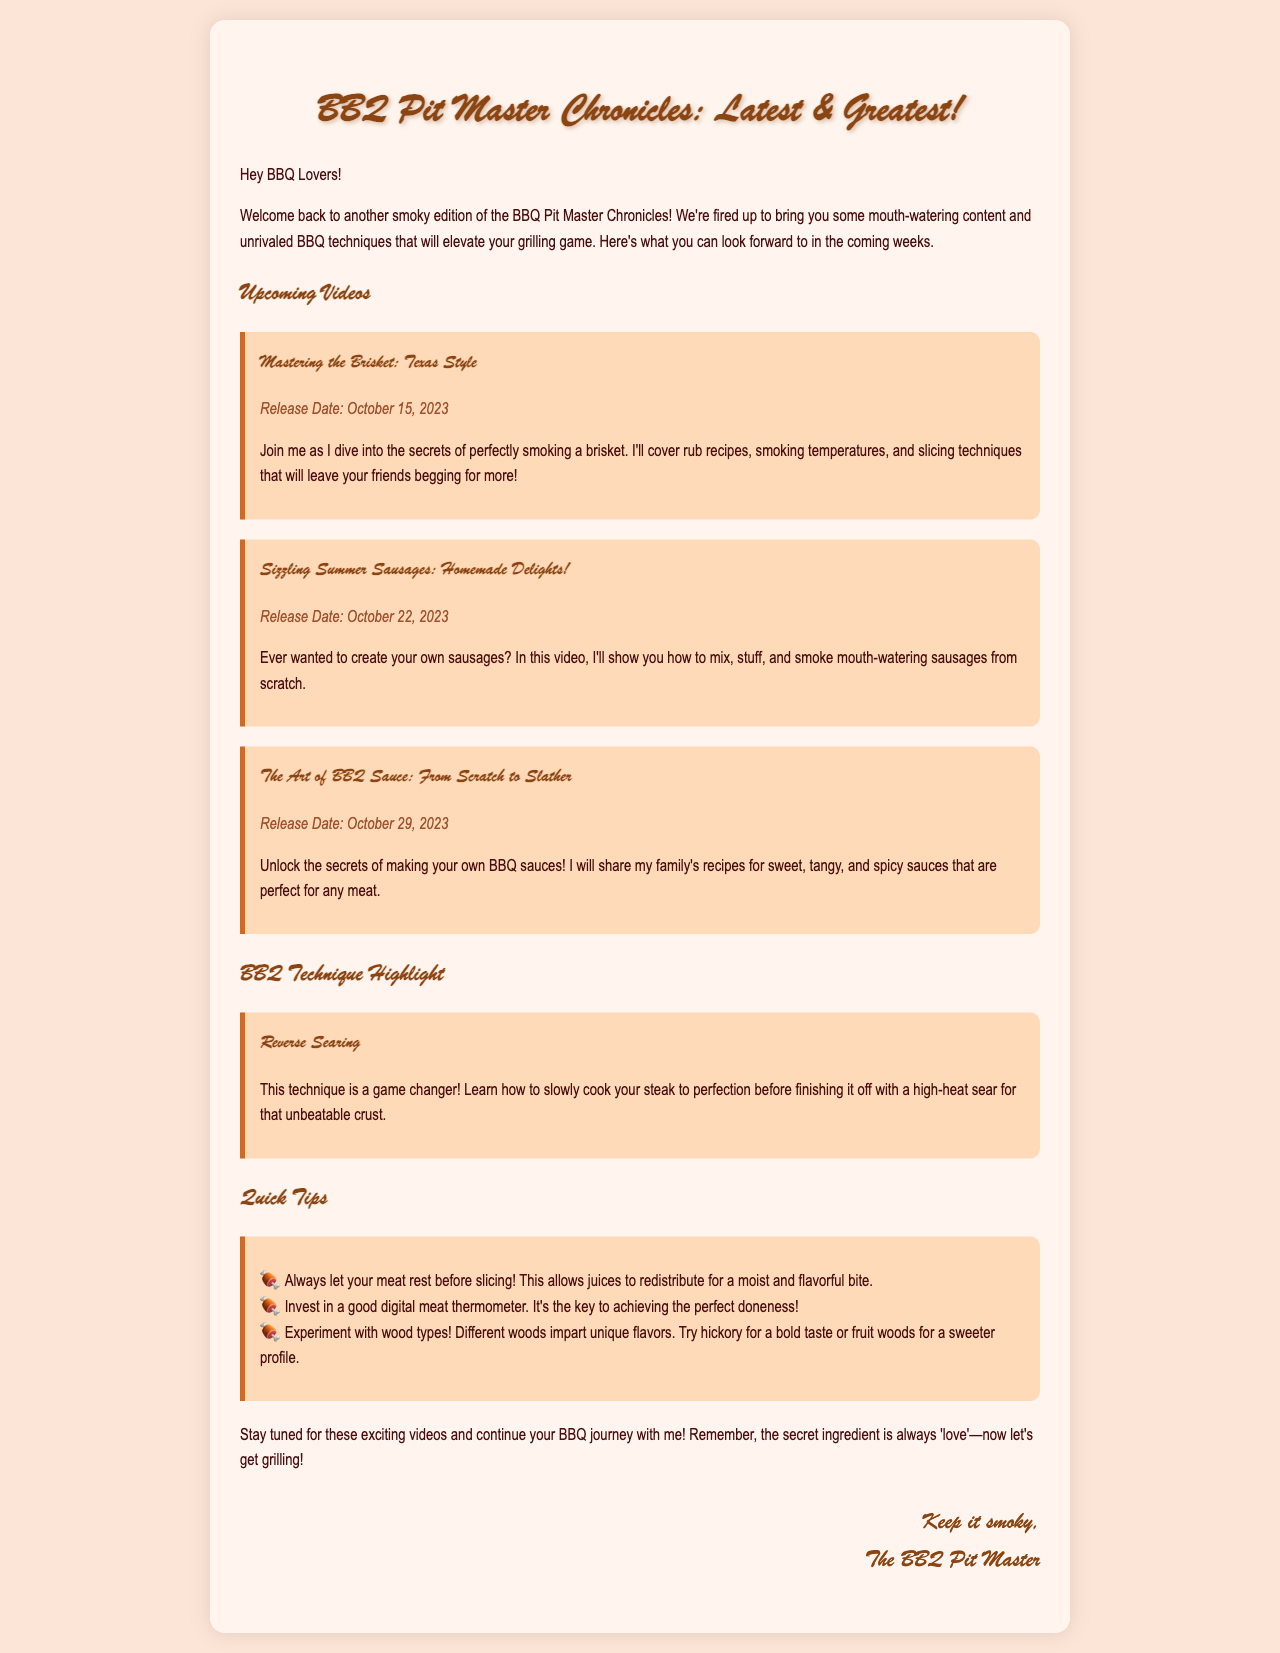What is the title of the newsletter? The title is presented prominently at the top of the document, highlighting the theme of the newsletter.
Answer: BBQ Pit Master Chronicles: Latest & Greatest! What video will be released on October 15, 2023? The document specifies the release date and corresponding video, detailing the content to be covered in that video.
Answer: Mastering the Brisket: Texas Style How many videos are mentioned in the newsletter? The newsletter lists three upcoming videos, indicating the variety of content for the subscribers.
Answer: Three What technique is highlighted in the document? The document features a specific BBQ technique, which is emphasized to educate the readers on important grilling methods.
Answer: Reverse Searing What should you do before slicing meat? A quick tip is provided in the tips section of the document to aid BBQ enthusiasts in improving their results.
Answer: Let your meat rest What is one wood type mentioned for smoking? The document encourages experimentation with different wood types for flavor and specifically mentions a wood type as an example.
Answer: Hickory What are the release dates of the upcoming videos? The document provides specific dates for each video release, showcasing the schedule for subscribers.
Answer: October 15, 22, and 29, 2023 Who is the sign-off in the newsletter? The document concludes with a signature that represents the author, further personalizing the communication.
Answer: The BBQ Pit Master 